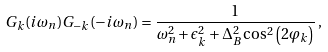<formula> <loc_0><loc_0><loc_500><loc_500>G _ { k } ( i \omega _ { n } ) G _ { - k } ( - i \omega _ { n } ) = \frac { 1 } { \omega _ { n } ^ { 2 } + \epsilon ^ { 2 } _ { k } + \Delta _ { B } ^ { 2 } \cos ^ { 2 } \left ( 2 \varphi _ { k } \right ) } \, ,</formula> 